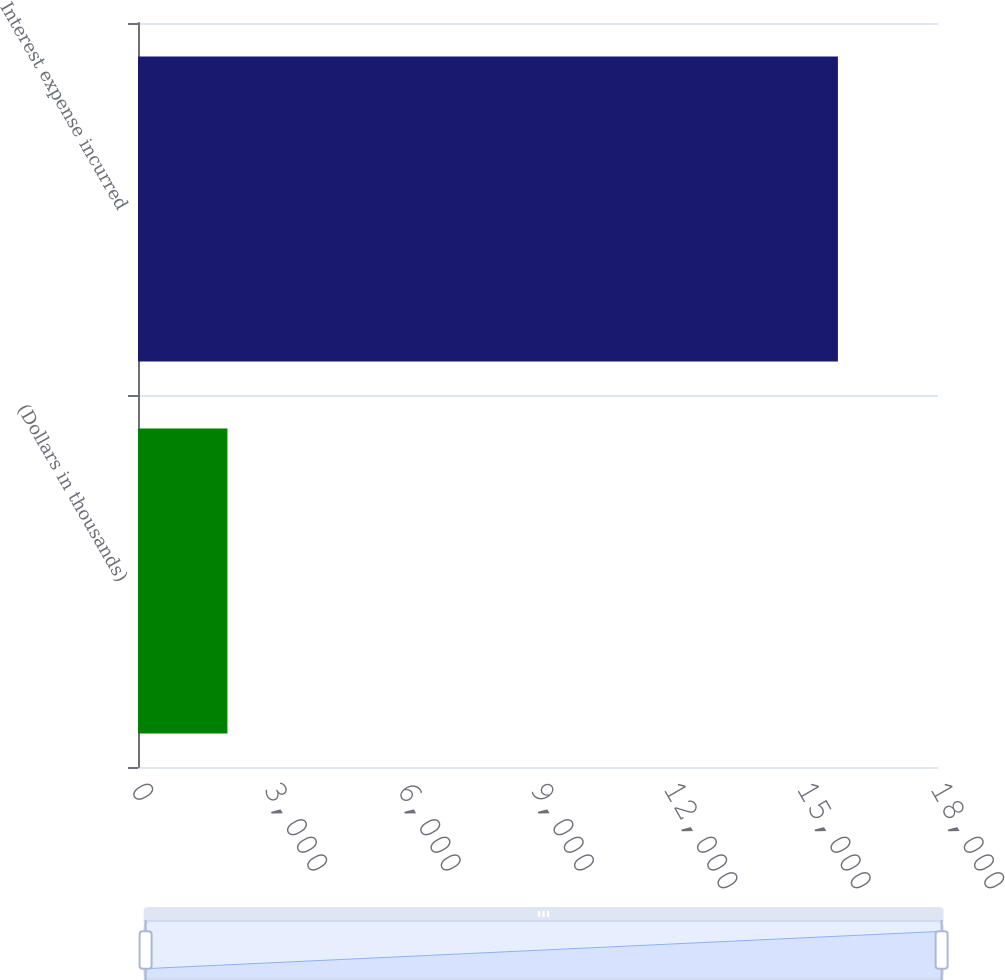<chart> <loc_0><loc_0><loc_500><loc_500><bar_chart><fcel>(Dollars in thousands)<fcel>Interest expense incurred<nl><fcel>2012<fcel>15748<nl></chart> 